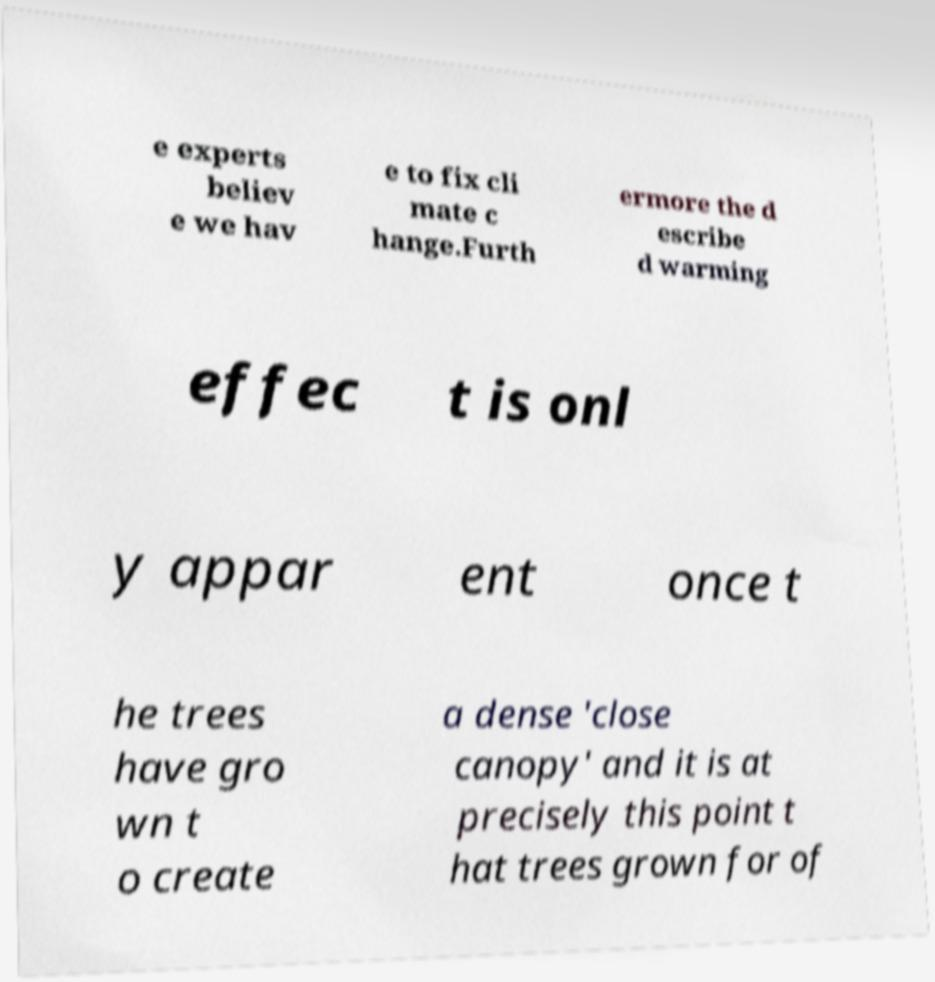Could you extract and type out the text from this image? e experts believ e we hav e to fix cli mate c hange.Furth ermore the d escribe d warming effec t is onl y appar ent once t he trees have gro wn t o create a dense 'close canopy' and it is at precisely this point t hat trees grown for of 